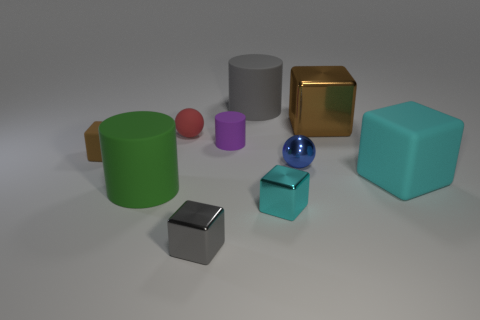Do the big metal thing and the tiny matte block have the same color?
Ensure brevity in your answer.  Yes. There is a brown cube that is to the right of the tiny metallic block to the right of the large gray cylinder; what is it made of?
Make the answer very short. Metal. How big is the matte thing in front of the cyan object that is to the right of the tiny blue object behind the tiny cyan thing?
Keep it short and to the point. Large. Does the red object have the same size as the purple rubber cylinder?
Your response must be concise. Yes. There is a cyan thing to the left of the large cyan matte cube; is it the same shape as the tiny thing to the left of the small red matte thing?
Offer a terse response. Yes. Is there a tiny purple rubber cylinder to the left of the rubber thing to the right of the big gray cylinder?
Provide a short and direct response. Yes. Are there any brown metallic cylinders?
Your answer should be compact. No. What number of other things are the same size as the green matte object?
Give a very brief answer. 3. How many tiny cubes are in front of the metallic sphere and on the left side of the gray shiny object?
Your answer should be very brief. 0. There is a brown block that is to the right of the green cylinder; does it have the same size as the small rubber cylinder?
Keep it short and to the point. No. 